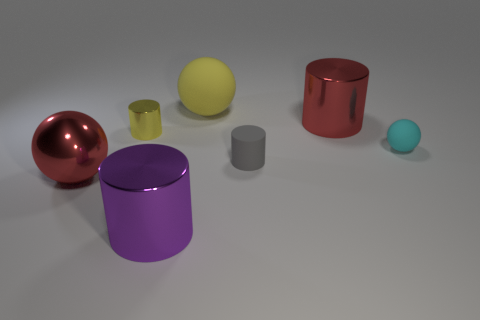Does the big yellow ball have the same material as the tiny object that is left of the large purple shiny cylinder?
Offer a very short reply. No. Is there a cyan ball that has the same size as the purple metal object?
Offer a terse response. No. Are there the same number of red balls that are right of the red metal sphere and tiny cyan things?
Provide a succinct answer. No. The cyan ball has what size?
Your answer should be compact. Small. There is a shiny sphere that is left of the big yellow matte sphere; how many spheres are behind it?
Provide a succinct answer. 2. What shape is the object that is both left of the tiny cyan matte ball and right of the gray thing?
Your response must be concise. Cylinder. What number of tiny things are the same color as the tiny ball?
Make the answer very short. 0. There is a thing that is in front of the red object that is left of the gray rubber object; are there any tiny yellow cylinders on the left side of it?
Keep it short and to the point. Yes. There is a ball that is both in front of the yellow cylinder and on the right side of the purple object; how big is it?
Your answer should be compact. Small. What number of tiny yellow objects have the same material as the cyan object?
Offer a terse response. 0. 